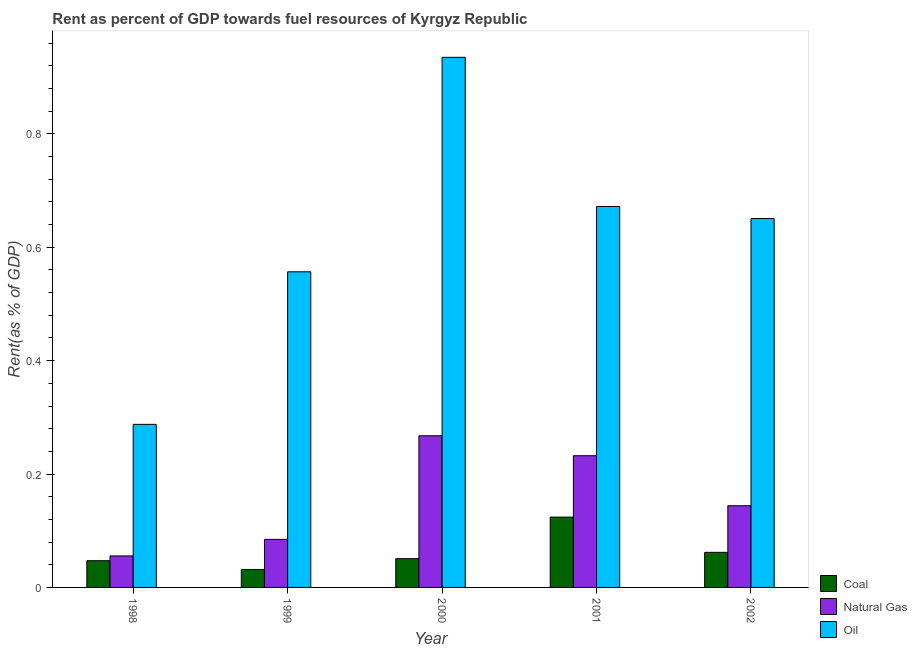How many different coloured bars are there?
Offer a very short reply. 3. How many groups of bars are there?
Keep it short and to the point. 5. Are the number of bars on each tick of the X-axis equal?
Offer a very short reply. Yes. How many bars are there on the 4th tick from the left?
Make the answer very short. 3. How many bars are there on the 5th tick from the right?
Make the answer very short. 3. What is the rent towards coal in 1998?
Offer a very short reply. 0.05. Across all years, what is the maximum rent towards oil?
Ensure brevity in your answer.  0.94. Across all years, what is the minimum rent towards coal?
Offer a terse response. 0.03. What is the total rent towards natural gas in the graph?
Your answer should be compact. 0.78. What is the difference between the rent towards coal in 1999 and that in 2002?
Ensure brevity in your answer.  -0.03. What is the difference between the rent towards oil in 1999 and the rent towards coal in 1998?
Ensure brevity in your answer.  0.27. What is the average rent towards coal per year?
Your response must be concise. 0.06. In how many years, is the rent towards oil greater than 0.7600000000000001 %?
Your answer should be very brief. 1. What is the ratio of the rent towards natural gas in 1998 to that in 2001?
Your response must be concise. 0.24. Is the difference between the rent towards coal in 1998 and 2002 greater than the difference between the rent towards oil in 1998 and 2002?
Your response must be concise. No. What is the difference between the highest and the second highest rent towards natural gas?
Provide a succinct answer. 0.04. What is the difference between the highest and the lowest rent towards natural gas?
Ensure brevity in your answer.  0.21. In how many years, is the rent towards natural gas greater than the average rent towards natural gas taken over all years?
Offer a very short reply. 2. Is the sum of the rent towards natural gas in 1999 and 2002 greater than the maximum rent towards coal across all years?
Offer a very short reply. No. What does the 1st bar from the left in 2001 represents?
Make the answer very short. Coal. What does the 1st bar from the right in 1999 represents?
Your answer should be very brief. Oil. Is it the case that in every year, the sum of the rent towards coal and rent towards natural gas is greater than the rent towards oil?
Offer a very short reply. No. How many years are there in the graph?
Ensure brevity in your answer.  5. Are the values on the major ticks of Y-axis written in scientific E-notation?
Your response must be concise. No. Does the graph contain any zero values?
Your response must be concise. No. Does the graph contain grids?
Your answer should be very brief. No. Where does the legend appear in the graph?
Your response must be concise. Bottom right. How are the legend labels stacked?
Your answer should be compact. Vertical. What is the title of the graph?
Provide a short and direct response. Rent as percent of GDP towards fuel resources of Kyrgyz Republic. What is the label or title of the X-axis?
Keep it short and to the point. Year. What is the label or title of the Y-axis?
Make the answer very short. Rent(as % of GDP). What is the Rent(as % of GDP) in Coal in 1998?
Keep it short and to the point. 0.05. What is the Rent(as % of GDP) of Natural Gas in 1998?
Give a very brief answer. 0.06. What is the Rent(as % of GDP) in Oil in 1998?
Your response must be concise. 0.29. What is the Rent(as % of GDP) of Coal in 1999?
Your response must be concise. 0.03. What is the Rent(as % of GDP) of Natural Gas in 1999?
Your answer should be compact. 0.08. What is the Rent(as % of GDP) of Oil in 1999?
Your answer should be compact. 0.56. What is the Rent(as % of GDP) in Coal in 2000?
Offer a very short reply. 0.05. What is the Rent(as % of GDP) of Natural Gas in 2000?
Give a very brief answer. 0.27. What is the Rent(as % of GDP) in Oil in 2000?
Make the answer very short. 0.94. What is the Rent(as % of GDP) in Coal in 2001?
Provide a succinct answer. 0.12. What is the Rent(as % of GDP) in Natural Gas in 2001?
Your answer should be very brief. 0.23. What is the Rent(as % of GDP) in Oil in 2001?
Your response must be concise. 0.67. What is the Rent(as % of GDP) in Coal in 2002?
Make the answer very short. 0.06. What is the Rent(as % of GDP) in Natural Gas in 2002?
Give a very brief answer. 0.14. What is the Rent(as % of GDP) of Oil in 2002?
Offer a terse response. 0.65. Across all years, what is the maximum Rent(as % of GDP) of Coal?
Your answer should be compact. 0.12. Across all years, what is the maximum Rent(as % of GDP) in Natural Gas?
Your answer should be compact. 0.27. Across all years, what is the maximum Rent(as % of GDP) in Oil?
Give a very brief answer. 0.94. Across all years, what is the minimum Rent(as % of GDP) in Coal?
Ensure brevity in your answer.  0.03. Across all years, what is the minimum Rent(as % of GDP) in Natural Gas?
Your response must be concise. 0.06. Across all years, what is the minimum Rent(as % of GDP) of Oil?
Your response must be concise. 0.29. What is the total Rent(as % of GDP) of Coal in the graph?
Keep it short and to the point. 0.32. What is the total Rent(as % of GDP) in Natural Gas in the graph?
Your response must be concise. 0.78. What is the total Rent(as % of GDP) in Oil in the graph?
Offer a very short reply. 3.1. What is the difference between the Rent(as % of GDP) of Coal in 1998 and that in 1999?
Your answer should be very brief. 0.02. What is the difference between the Rent(as % of GDP) in Natural Gas in 1998 and that in 1999?
Ensure brevity in your answer.  -0.03. What is the difference between the Rent(as % of GDP) in Oil in 1998 and that in 1999?
Offer a very short reply. -0.27. What is the difference between the Rent(as % of GDP) of Coal in 1998 and that in 2000?
Offer a terse response. -0. What is the difference between the Rent(as % of GDP) in Natural Gas in 1998 and that in 2000?
Ensure brevity in your answer.  -0.21. What is the difference between the Rent(as % of GDP) of Oil in 1998 and that in 2000?
Give a very brief answer. -0.65. What is the difference between the Rent(as % of GDP) in Coal in 1998 and that in 2001?
Your answer should be very brief. -0.08. What is the difference between the Rent(as % of GDP) in Natural Gas in 1998 and that in 2001?
Provide a short and direct response. -0.18. What is the difference between the Rent(as % of GDP) of Oil in 1998 and that in 2001?
Make the answer very short. -0.38. What is the difference between the Rent(as % of GDP) of Coal in 1998 and that in 2002?
Your response must be concise. -0.01. What is the difference between the Rent(as % of GDP) of Natural Gas in 1998 and that in 2002?
Make the answer very short. -0.09. What is the difference between the Rent(as % of GDP) of Oil in 1998 and that in 2002?
Your answer should be compact. -0.36. What is the difference between the Rent(as % of GDP) in Coal in 1999 and that in 2000?
Make the answer very short. -0.02. What is the difference between the Rent(as % of GDP) of Natural Gas in 1999 and that in 2000?
Offer a terse response. -0.18. What is the difference between the Rent(as % of GDP) of Oil in 1999 and that in 2000?
Offer a very short reply. -0.38. What is the difference between the Rent(as % of GDP) of Coal in 1999 and that in 2001?
Your answer should be very brief. -0.09. What is the difference between the Rent(as % of GDP) in Natural Gas in 1999 and that in 2001?
Give a very brief answer. -0.15. What is the difference between the Rent(as % of GDP) of Oil in 1999 and that in 2001?
Your answer should be compact. -0.12. What is the difference between the Rent(as % of GDP) of Coal in 1999 and that in 2002?
Ensure brevity in your answer.  -0.03. What is the difference between the Rent(as % of GDP) of Natural Gas in 1999 and that in 2002?
Your response must be concise. -0.06. What is the difference between the Rent(as % of GDP) of Oil in 1999 and that in 2002?
Provide a short and direct response. -0.09. What is the difference between the Rent(as % of GDP) in Coal in 2000 and that in 2001?
Provide a succinct answer. -0.07. What is the difference between the Rent(as % of GDP) of Natural Gas in 2000 and that in 2001?
Your answer should be compact. 0.04. What is the difference between the Rent(as % of GDP) in Oil in 2000 and that in 2001?
Offer a very short reply. 0.26. What is the difference between the Rent(as % of GDP) in Coal in 2000 and that in 2002?
Provide a succinct answer. -0.01. What is the difference between the Rent(as % of GDP) of Natural Gas in 2000 and that in 2002?
Keep it short and to the point. 0.12. What is the difference between the Rent(as % of GDP) in Oil in 2000 and that in 2002?
Provide a succinct answer. 0.28. What is the difference between the Rent(as % of GDP) in Coal in 2001 and that in 2002?
Keep it short and to the point. 0.06. What is the difference between the Rent(as % of GDP) in Natural Gas in 2001 and that in 2002?
Your answer should be compact. 0.09. What is the difference between the Rent(as % of GDP) in Oil in 2001 and that in 2002?
Your answer should be compact. 0.02. What is the difference between the Rent(as % of GDP) of Coal in 1998 and the Rent(as % of GDP) of Natural Gas in 1999?
Your answer should be compact. -0.04. What is the difference between the Rent(as % of GDP) of Coal in 1998 and the Rent(as % of GDP) of Oil in 1999?
Keep it short and to the point. -0.51. What is the difference between the Rent(as % of GDP) of Natural Gas in 1998 and the Rent(as % of GDP) of Oil in 1999?
Ensure brevity in your answer.  -0.5. What is the difference between the Rent(as % of GDP) of Coal in 1998 and the Rent(as % of GDP) of Natural Gas in 2000?
Your answer should be very brief. -0.22. What is the difference between the Rent(as % of GDP) of Coal in 1998 and the Rent(as % of GDP) of Oil in 2000?
Provide a short and direct response. -0.89. What is the difference between the Rent(as % of GDP) of Natural Gas in 1998 and the Rent(as % of GDP) of Oil in 2000?
Provide a short and direct response. -0.88. What is the difference between the Rent(as % of GDP) in Coal in 1998 and the Rent(as % of GDP) in Natural Gas in 2001?
Make the answer very short. -0.19. What is the difference between the Rent(as % of GDP) in Coal in 1998 and the Rent(as % of GDP) in Oil in 2001?
Give a very brief answer. -0.62. What is the difference between the Rent(as % of GDP) in Natural Gas in 1998 and the Rent(as % of GDP) in Oil in 2001?
Provide a short and direct response. -0.62. What is the difference between the Rent(as % of GDP) of Coal in 1998 and the Rent(as % of GDP) of Natural Gas in 2002?
Your answer should be compact. -0.1. What is the difference between the Rent(as % of GDP) in Coal in 1998 and the Rent(as % of GDP) in Oil in 2002?
Keep it short and to the point. -0.6. What is the difference between the Rent(as % of GDP) of Natural Gas in 1998 and the Rent(as % of GDP) of Oil in 2002?
Provide a succinct answer. -0.6. What is the difference between the Rent(as % of GDP) of Coal in 1999 and the Rent(as % of GDP) of Natural Gas in 2000?
Your answer should be compact. -0.24. What is the difference between the Rent(as % of GDP) in Coal in 1999 and the Rent(as % of GDP) in Oil in 2000?
Provide a short and direct response. -0.9. What is the difference between the Rent(as % of GDP) of Natural Gas in 1999 and the Rent(as % of GDP) of Oil in 2000?
Offer a terse response. -0.85. What is the difference between the Rent(as % of GDP) in Coal in 1999 and the Rent(as % of GDP) in Natural Gas in 2001?
Ensure brevity in your answer.  -0.2. What is the difference between the Rent(as % of GDP) in Coal in 1999 and the Rent(as % of GDP) in Oil in 2001?
Offer a terse response. -0.64. What is the difference between the Rent(as % of GDP) of Natural Gas in 1999 and the Rent(as % of GDP) of Oil in 2001?
Give a very brief answer. -0.59. What is the difference between the Rent(as % of GDP) in Coal in 1999 and the Rent(as % of GDP) in Natural Gas in 2002?
Provide a succinct answer. -0.11. What is the difference between the Rent(as % of GDP) in Coal in 1999 and the Rent(as % of GDP) in Oil in 2002?
Your answer should be compact. -0.62. What is the difference between the Rent(as % of GDP) in Natural Gas in 1999 and the Rent(as % of GDP) in Oil in 2002?
Keep it short and to the point. -0.57. What is the difference between the Rent(as % of GDP) in Coal in 2000 and the Rent(as % of GDP) in Natural Gas in 2001?
Give a very brief answer. -0.18. What is the difference between the Rent(as % of GDP) of Coal in 2000 and the Rent(as % of GDP) of Oil in 2001?
Give a very brief answer. -0.62. What is the difference between the Rent(as % of GDP) in Natural Gas in 2000 and the Rent(as % of GDP) in Oil in 2001?
Your answer should be compact. -0.4. What is the difference between the Rent(as % of GDP) of Coal in 2000 and the Rent(as % of GDP) of Natural Gas in 2002?
Offer a terse response. -0.09. What is the difference between the Rent(as % of GDP) in Coal in 2000 and the Rent(as % of GDP) in Oil in 2002?
Make the answer very short. -0.6. What is the difference between the Rent(as % of GDP) in Natural Gas in 2000 and the Rent(as % of GDP) in Oil in 2002?
Your response must be concise. -0.38. What is the difference between the Rent(as % of GDP) in Coal in 2001 and the Rent(as % of GDP) in Natural Gas in 2002?
Your answer should be compact. -0.02. What is the difference between the Rent(as % of GDP) in Coal in 2001 and the Rent(as % of GDP) in Oil in 2002?
Offer a terse response. -0.53. What is the difference between the Rent(as % of GDP) in Natural Gas in 2001 and the Rent(as % of GDP) in Oil in 2002?
Keep it short and to the point. -0.42. What is the average Rent(as % of GDP) in Coal per year?
Keep it short and to the point. 0.06. What is the average Rent(as % of GDP) in Natural Gas per year?
Your response must be concise. 0.16. What is the average Rent(as % of GDP) of Oil per year?
Keep it short and to the point. 0.62. In the year 1998, what is the difference between the Rent(as % of GDP) of Coal and Rent(as % of GDP) of Natural Gas?
Make the answer very short. -0.01. In the year 1998, what is the difference between the Rent(as % of GDP) of Coal and Rent(as % of GDP) of Oil?
Your response must be concise. -0.24. In the year 1998, what is the difference between the Rent(as % of GDP) in Natural Gas and Rent(as % of GDP) in Oil?
Your response must be concise. -0.23. In the year 1999, what is the difference between the Rent(as % of GDP) in Coal and Rent(as % of GDP) in Natural Gas?
Make the answer very short. -0.05. In the year 1999, what is the difference between the Rent(as % of GDP) in Coal and Rent(as % of GDP) in Oil?
Offer a terse response. -0.53. In the year 1999, what is the difference between the Rent(as % of GDP) of Natural Gas and Rent(as % of GDP) of Oil?
Make the answer very short. -0.47. In the year 2000, what is the difference between the Rent(as % of GDP) in Coal and Rent(as % of GDP) in Natural Gas?
Give a very brief answer. -0.22. In the year 2000, what is the difference between the Rent(as % of GDP) in Coal and Rent(as % of GDP) in Oil?
Keep it short and to the point. -0.88. In the year 2000, what is the difference between the Rent(as % of GDP) in Natural Gas and Rent(as % of GDP) in Oil?
Offer a very short reply. -0.67. In the year 2001, what is the difference between the Rent(as % of GDP) in Coal and Rent(as % of GDP) in Natural Gas?
Keep it short and to the point. -0.11. In the year 2001, what is the difference between the Rent(as % of GDP) of Coal and Rent(as % of GDP) of Oil?
Make the answer very short. -0.55. In the year 2001, what is the difference between the Rent(as % of GDP) in Natural Gas and Rent(as % of GDP) in Oil?
Offer a very short reply. -0.44. In the year 2002, what is the difference between the Rent(as % of GDP) in Coal and Rent(as % of GDP) in Natural Gas?
Offer a very short reply. -0.08. In the year 2002, what is the difference between the Rent(as % of GDP) of Coal and Rent(as % of GDP) of Oil?
Your response must be concise. -0.59. In the year 2002, what is the difference between the Rent(as % of GDP) in Natural Gas and Rent(as % of GDP) in Oil?
Your response must be concise. -0.51. What is the ratio of the Rent(as % of GDP) in Coal in 1998 to that in 1999?
Your answer should be very brief. 1.49. What is the ratio of the Rent(as % of GDP) of Natural Gas in 1998 to that in 1999?
Your answer should be compact. 0.66. What is the ratio of the Rent(as % of GDP) of Oil in 1998 to that in 1999?
Make the answer very short. 0.52. What is the ratio of the Rent(as % of GDP) of Coal in 1998 to that in 2000?
Your response must be concise. 0.93. What is the ratio of the Rent(as % of GDP) in Natural Gas in 1998 to that in 2000?
Offer a very short reply. 0.21. What is the ratio of the Rent(as % of GDP) in Oil in 1998 to that in 2000?
Ensure brevity in your answer.  0.31. What is the ratio of the Rent(as % of GDP) of Coal in 1998 to that in 2001?
Offer a terse response. 0.38. What is the ratio of the Rent(as % of GDP) in Natural Gas in 1998 to that in 2001?
Offer a terse response. 0.24. What is the ratio of the Rent(as % of GDP) in Oil in 1998 to that in 2001?
Your answer should be very brief. 0.43. What is the ratio of the Rent(as % of GDP) of Coal in 1998 to that in 2002?
Offer a very short reply. 0.76. What is the ratio of the Rent(as % of GDP) in Natural Gas in 1998 to that in 2002?
Make the answer very short. 0.39. What is the ratio of the Rent(as % of GDP) in Oil in 1998 to that in 2002?
Provide a succinct answer. 0.44. What is the ratio of the Rent(as % of GDP) in Coal in 1999 to that in 2000?
Provide a short and direct response. 0.62. What is the ratio of the Rent(as % of GDP) in Natural Gas in 1999 to that in 2000?
Ensure brevity in your answer.  0.32. What is the ratio of the Rent(as % of GDP) in Oil in 1999 to that in 2000?
Your response must be concise. 0.6. What is the ratio of the Rent(as % of GDP) of Coal in 1999 to that in 2001?
Provide a succinct answer. 0.26. What is the ratio of the Rent(as % of GDP) in Natural Gas in 1999 to that in 2001?
Keep it short and to the point. 0.36. What is the ratio of the Rent(as % of GDP) of Oil in 1999 to that in 2001?
Your answer should be compact. 0.83. What is the ratio of the Rent(as % of GDP) of Coal in 1999 to that in 2002?
Your response must be concise. 0.51. What is the ratio of the Rent(as % of GDP) in Natural Gas in 1999 to that in 2002?
Ensure brevity in your answer.  0.59. What is the ratio of the Rent(as % of GDP) in Oil in 1999 to that in 2002?
Offer a very short reply. 0.86. What is the ratio of the Rent(as % of GDP) in Coal in 2000 to that in 2001?
Make the answer very short. 0.41. What is the ratio of the Rent(as % of GDP) of Natural Gas in 2000 to that in 2001?
Your answer should be very brief. 1.15. What is the ratio of the Rent(as % of GDP) in Oil in 2000 to that in 2001?
Your response must be concise. 1.39. What is the ratio of the Rent(as % of GDP) in Coal in 2000 to that in 2002?
Provide a succinct answer. 0.82. What is the ratio of the Rent(as % of GDP) of Natural Gas in 2000 to that in 2002?
Keep it short and to the point. 1.86. What is the ratio of the Rent(as % of GDP) in Oil in 2000 to that in 2002?
Provide a short and direct response. 1.44. What is the ratio of the Rent(as % of GDP) in Coal in 2001 to that in 2002?
Give a very brief answer. 2. What is the ratio of the Rent(as % of GDP) of Natural Gas in 2001 to that in 2002?
Offer a terse response. 1.61. What is the ratio of the Rent(as % of GDP) in Oil in 2001 to that in 2002?
Your answer should be very brief. 1.03. What is the difference between the highest and the second highest Rent(as % of GDP) of Coal?
Keep it short and to the point. 0.06. What is the difference between the highest and the second highest Rent(as % of GDP) of Natural Gas?
Your answer should be compact. 0.04. What is the difference between the highest and the second highest Rent(as % of GDP) in Oil?
Make the answer very short. 0.26. What is the difference between the highest and the lowest Rent(as % of GDP) in Coal?
Provide a succinct answer. 0.09. What is the difference between the highest and the lowest Rent(as % of GDP) of Natural Gas?
Offer a very short reply. 0.21. What is the difference between the highest and the lowest Rent(as % of GDP) of Oil?
Your response must be concise. 0.65. 